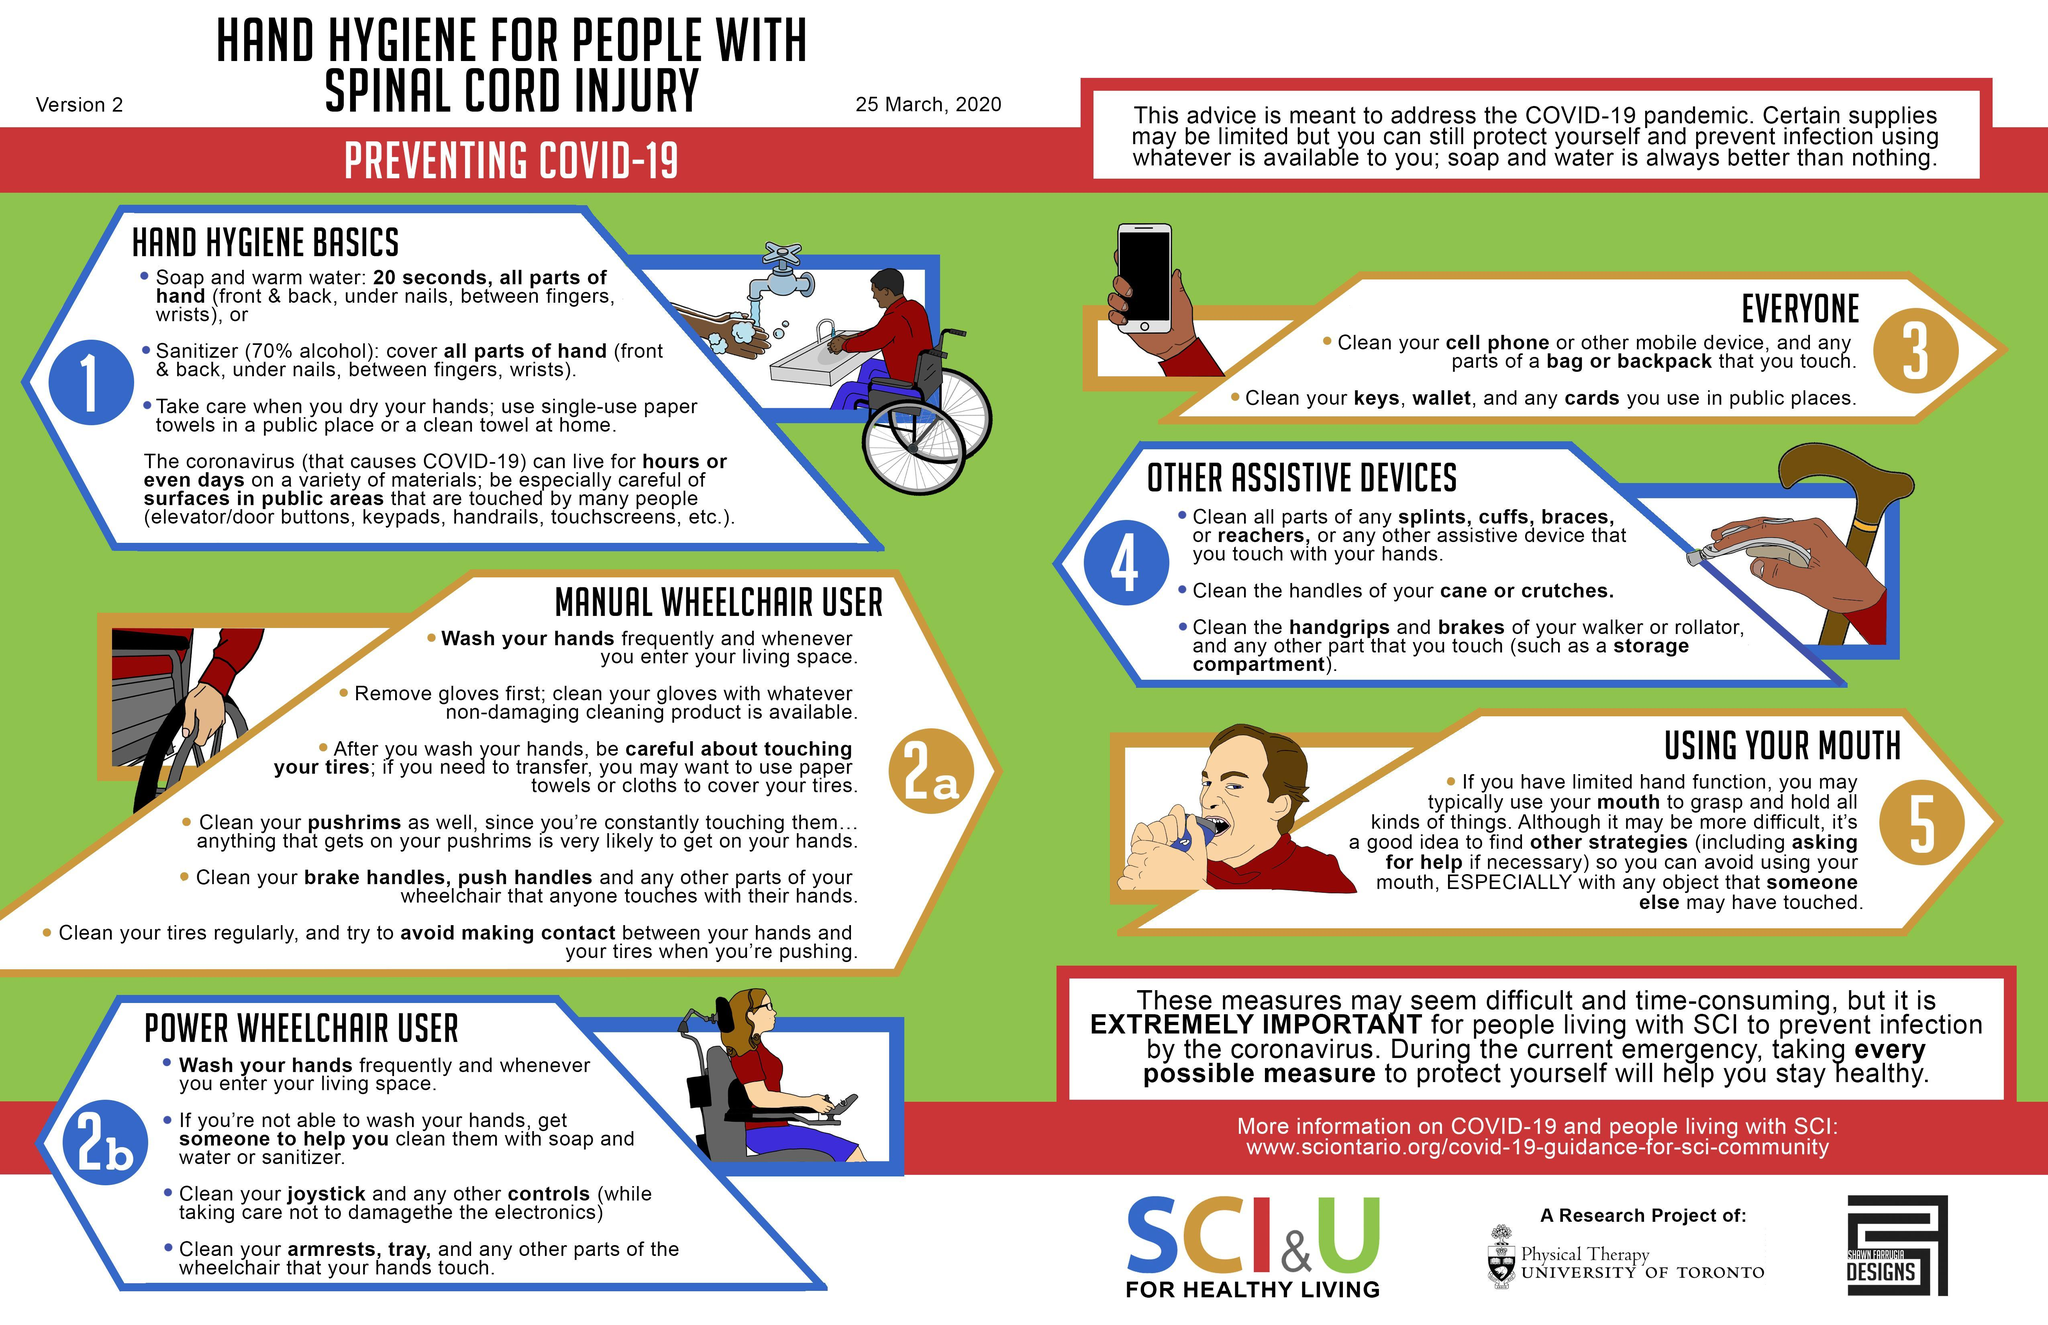How many bullet points are there under 'hand hygiene basics'?
Answer the question with a short phrase. 3 What are the common 'surfaces in public areas' that you should be concerned of? Elevator/door buttons, keypads, handrails, touchscreens Which are the handles on the manual wheelchair that require cleaning? Brake handles, push handles What part of canes/crutches, should users ensure to keep clean? Handles Which are the electronic parts, on the power wheelchair that require cleaning? Joystick, controls According to the instructions what can be used instead of soap and warm water? Sanitizer What is the third bullet point under section 2b? Clean your joystick and any other controls (while taking care not to damage the electronics) Which regions of the hand should be carefully cleaned with sanitizer? Front & back, under nails, between fingers, wrists How many precautionary measures are mentioned specifically for the power wheelchair user? 4 Which are the assistive devices mentioned in the first point of section 4? Splints, cuffs, braces, reachers How many bullet points are there under 'other assistive devices'? 3 What are wheelchair users instructed to do, when 'entering their living space'? Wash your hands What is the second point under section 3? Clean your keys, wallet, and any cards you use in public places What are they instructed to use to dry their hands, when not at home? Single use paper towels 